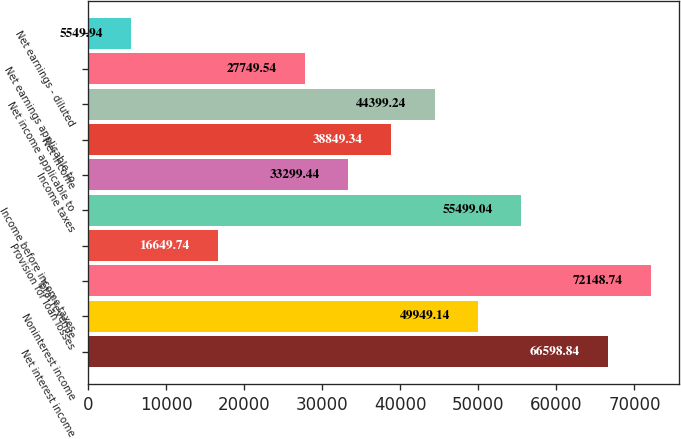Convert chart. <chart><loc_0><loc_0><loc_500><loc_500><bar_chart><fcel>Net interest income<fcel>Noninterest income<fcel>Total revenue<fcel>Provision for loan losses<fcel>Income before income taxes<fcel>Income taxes<fcel>Net income<fcel>Net income applicable to<fcel>Net earnings applicable to<fcel>Net earnings - diluted<nl><fcel>66598.8<fcel>49949.1<fcel>72148.7<fcel>16649.7<fcel>55499<fcel>33299.4<fcel>38849.3<fcel>44399.2<fcel>27749.5<fcel>5549.94<nl></chart> 